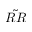Convert formula to latex. <formula><loc_0><loc_0><loc_500><loc_500>\tilde { R R }</formula> 